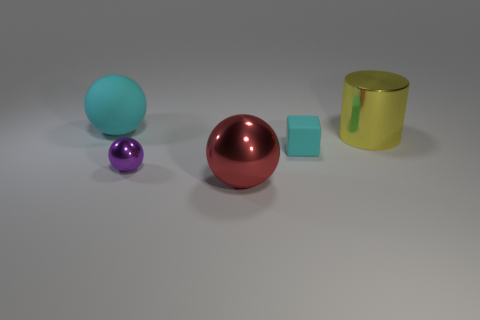How many objects are small cyan blocks or cyan objects that are in front of the large matte ball?
Your answer should be compact. 1. How many other objects are there of the same material as the big red object?
Offer a very short reply. 2. What number of things are small gray matte spheres or matte things?
Give a very brief answer. 2. Is the number of small cyan cubes that are to the right of the large cyan ball greater than the number of shiny balls right of the purple shiny thing?
Offer a very short reply. No. There is a large thing that is to the left of the small purple ball; is it the same color as the big metallic thing that is in front of the large cylinder?
Keep it short and to the point. No. There is a yellow metallic cylinder right of the purple thing in front of the cyan matte thing that is behind the small cyan rubber cube; what is its size?
Your answer should be compact. Large. The other metallic thing that is the same shape as the red shiny object is what color?
Provide a succinct answer. Purple. Are there more small purple balls on the right side of the tiny cyan matte cube than tiny blue blocks?
Offer a very short reply. No. Do the yellow thing and the cyan matte object behind the tiny cyan object have the same shape?
Give a very brief answer. No. Is there any other thing that is the same size as the yellow metallic cylinder?
Make the answer very short. Yes. 